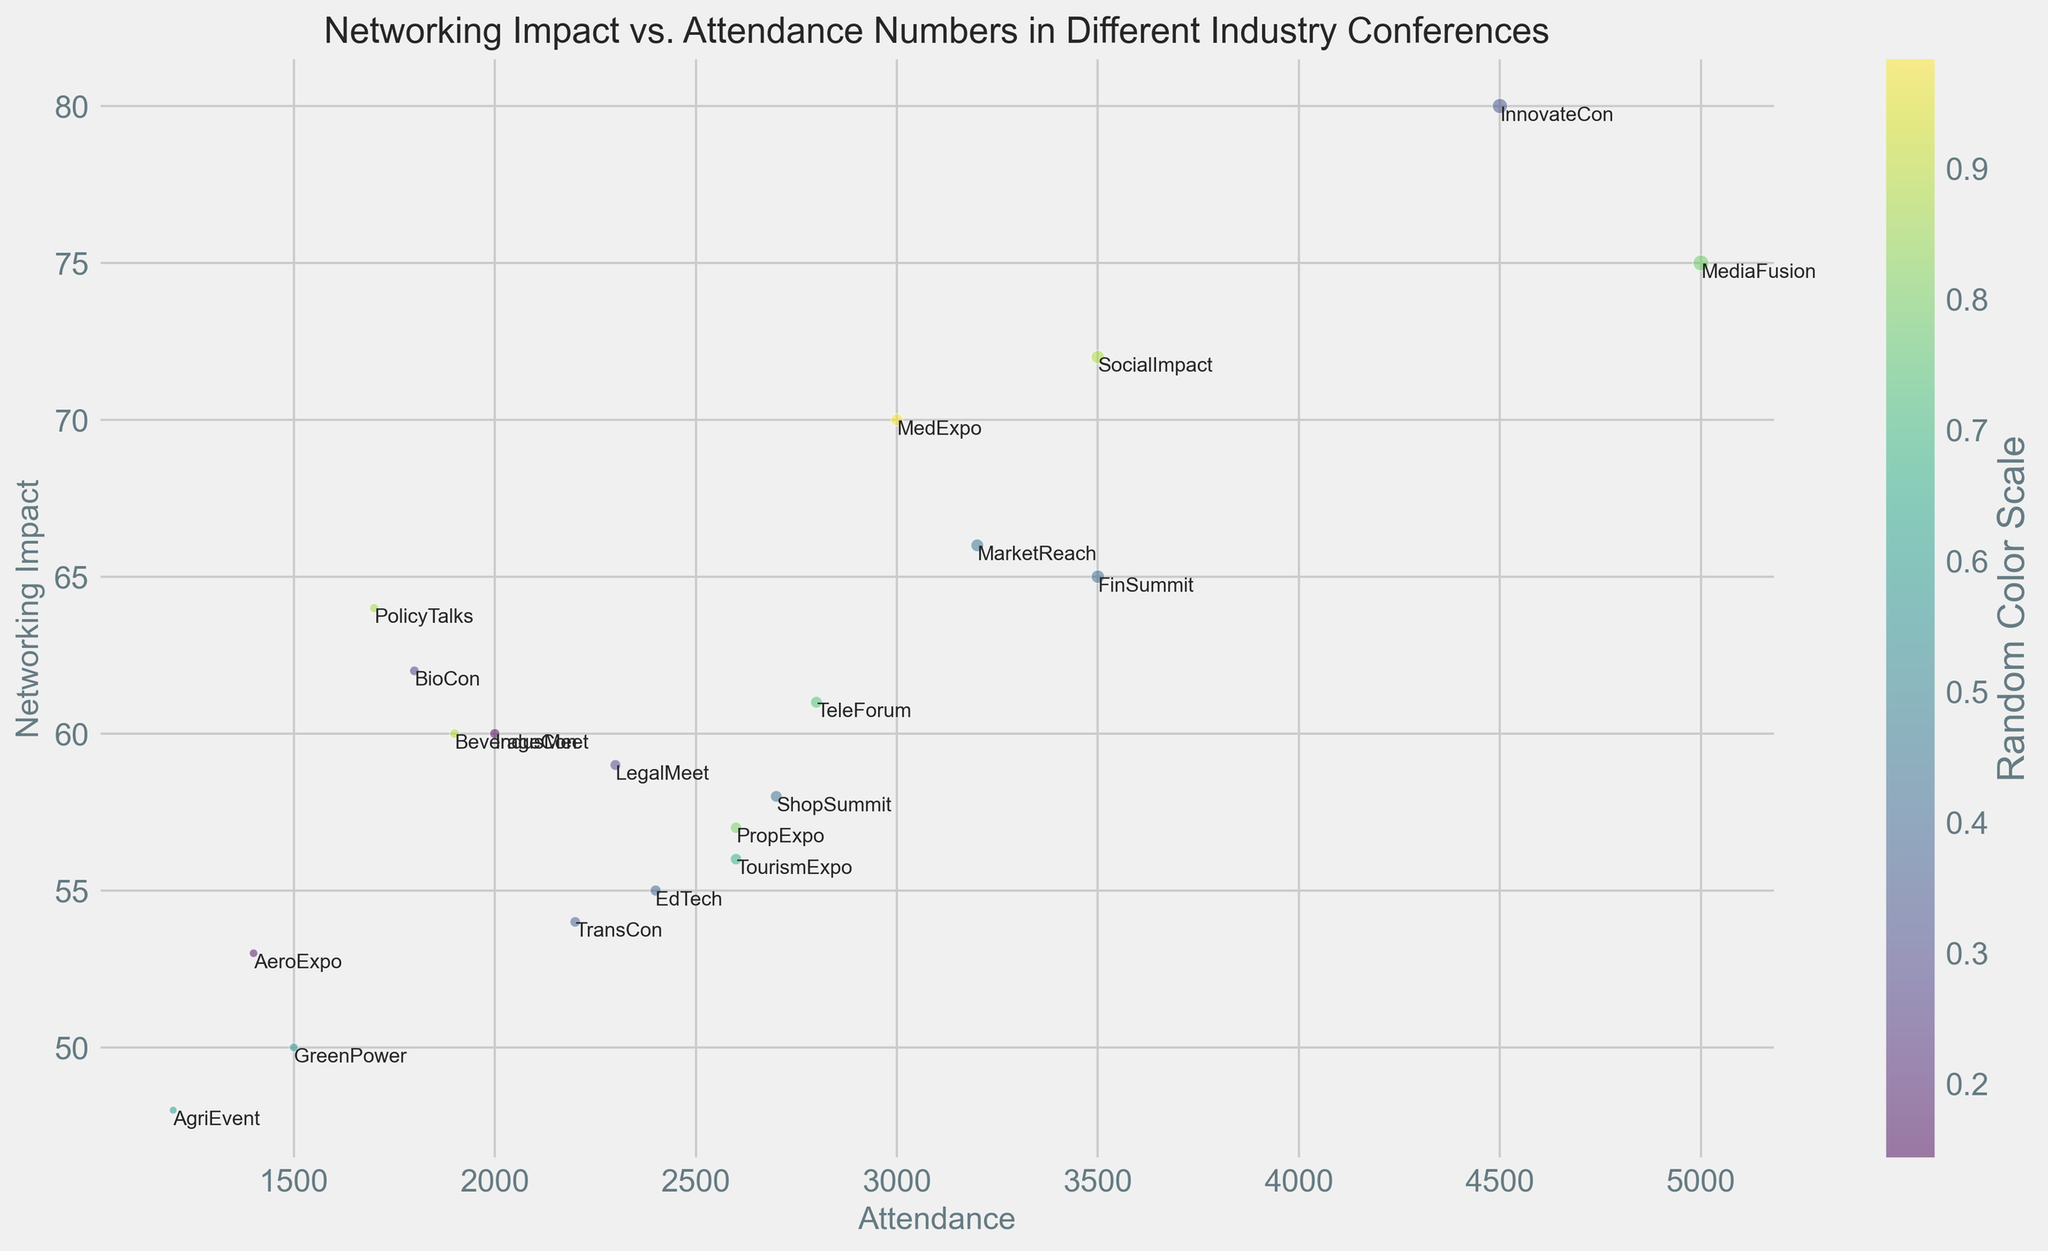What's the conference with the highest attendance? Look for the largest bubble on the x-axis, which represents attendance. The largest bubble corresponds to MediaFusion with an attendance of 5000.
Answer: MediaFusion Which conference has the lowest networking impact? Identify the lowest point on the y-axis, which represents networking impact. The lowest point corresponds to AgriEvent, with a networking impact score of 48.
Answer: AgriEvent How many conferences have a networking impact greater than 60? Count the number of bubbles above the y-axis value of 60. These conferences are InnovateCon, MedExpo, SocialImpact, BioCon, PolicyTalks, MarketReach, and LegalMeet.
Answer: 7 Which conferences have both attendance and networking impact below 2000 and 60, respectively? Look for bubbles in the bottom-left quadrant where both x-axis (attendance) is below 2000 and y-axis (networking impact) is below 60. The conferences are GreenPower, AeroExpo, AgriEvent, and BeverageCon.
Answer: GreenPower, AeroExpo, AgriEvent, BeverageCon Which industry conference has the median attendance? List all attendance values and find the median. When ordered (1200, 1400, 1500, 1700, 1800, 1900, 2000, 2200, 2300, 2400, 2600, 2600, 2700, 2800, 3000, 3200, 3500, 3500, 4500, 5000), the median value is 2400, which corresponds to EdTech.
Answer: EdTech Compare the attendance of EdTech and MarketReach conferences. Which one has higher attendance? Compare the x-axis positions of both EdTech and MarketReach. MarketReach has an attendance of 3200, which is higher than EdTech's 2400.
Answer: MarketReach Which two conferences have the closest networking impact scores? Look for the smallest vertical distance between two bubbles on the y-axis. Conferences TransCon and EdTech have very close networking impact scores of 54 and 55, respectively.
Answer: TransCon and EdTech What is the average networking impact of conferences with more than 3000 attendees? Identify conferences with attendance > 3000: InnovateCon, MediaFusion, SocialImpact. Average their impact: (80 + 75 + 72) / 3 = 75.67.
Answer: 75.67 Which conference has the least number of attendees but a networking impact above 50? Identify the smallest bubble with a y-axis value > 50. GreenPower has the least attendees (1500) with an impact above 50 (networking impact of 50).
Answer: GreenPower 